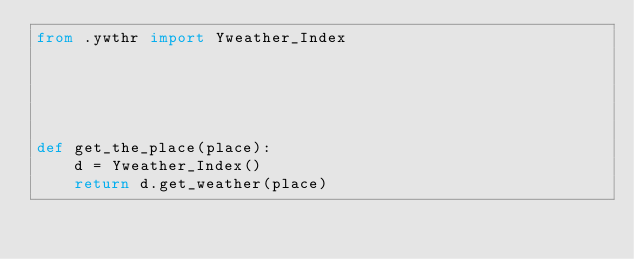Convert code to text. <code><loc_0><loc_0><loc_500><loc_500><_Python_>from .ywthr import Yweather_Index





def get_the_place(place):
	d = Yweather_Index()
	return d.get_weather(place)</code> 